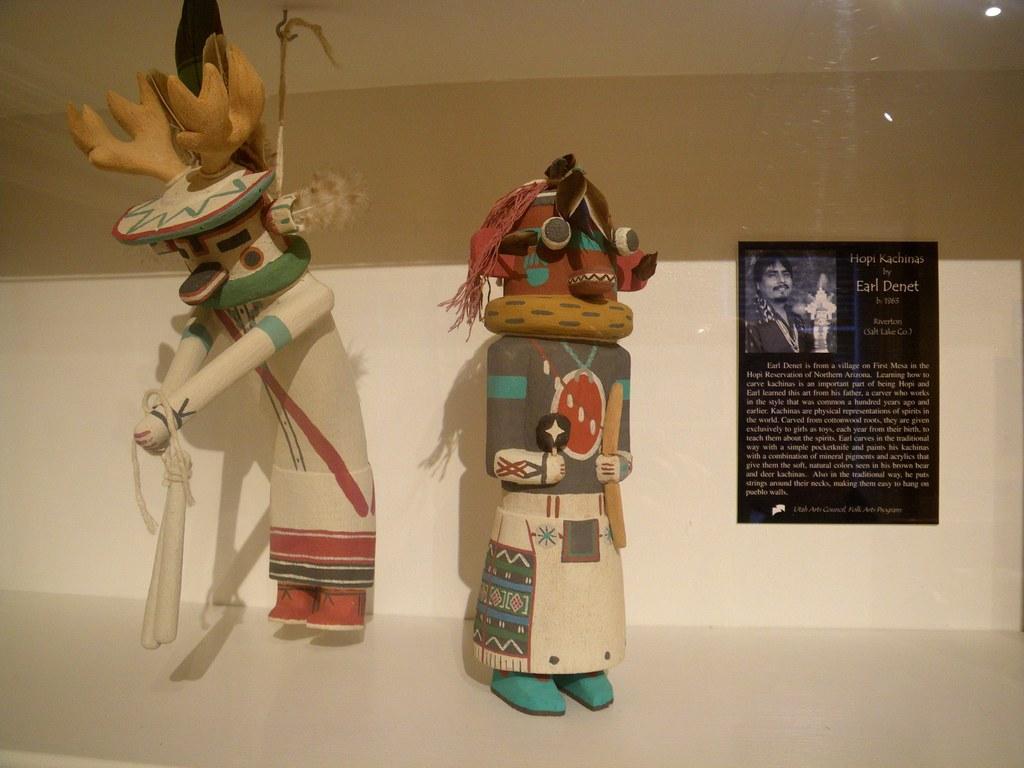Can you describe this image briefly? In this image we can see dolls placed on the floor and a wall hanging. 